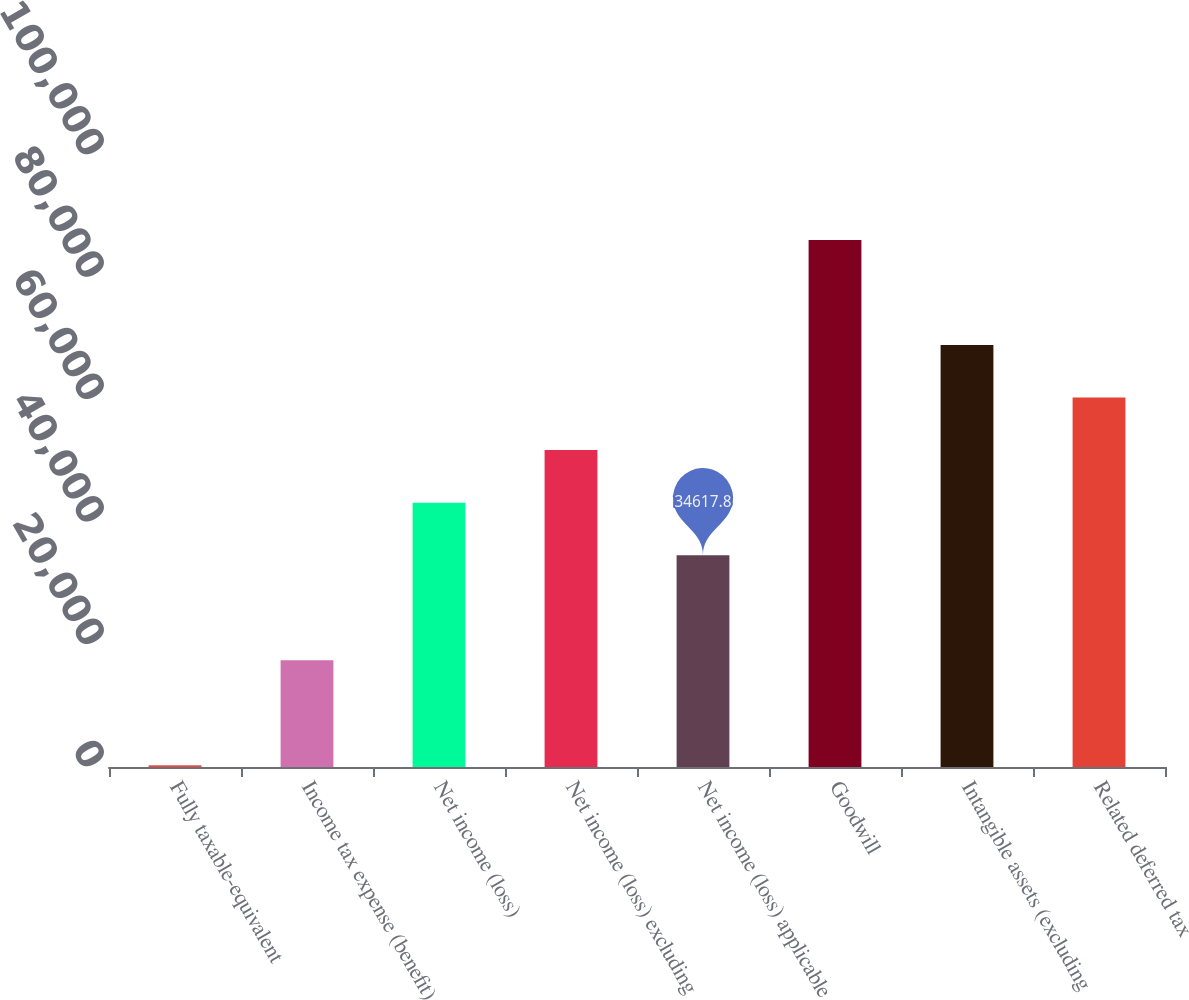<chart> <loc_0><loc_0><loc_500><loc_500><bar_chart><fcel>Fully taxable-equivalent<fcel>Income tax expense (benefit)<fcel>Net income (loss)<fcel>Net income (loss) excluding<fcel>Net income (loss) applicable<fcel>Goodwill<fcel>Intangible assets (excluding<fcel>Related deferred tax<nl><fcel>297<fcel>17457.4<fcel>43198<fcel>51778.2<fcel>34617.8<fcel>86099<fcel>68938.6<fcel>60358.4<nl></chart> 